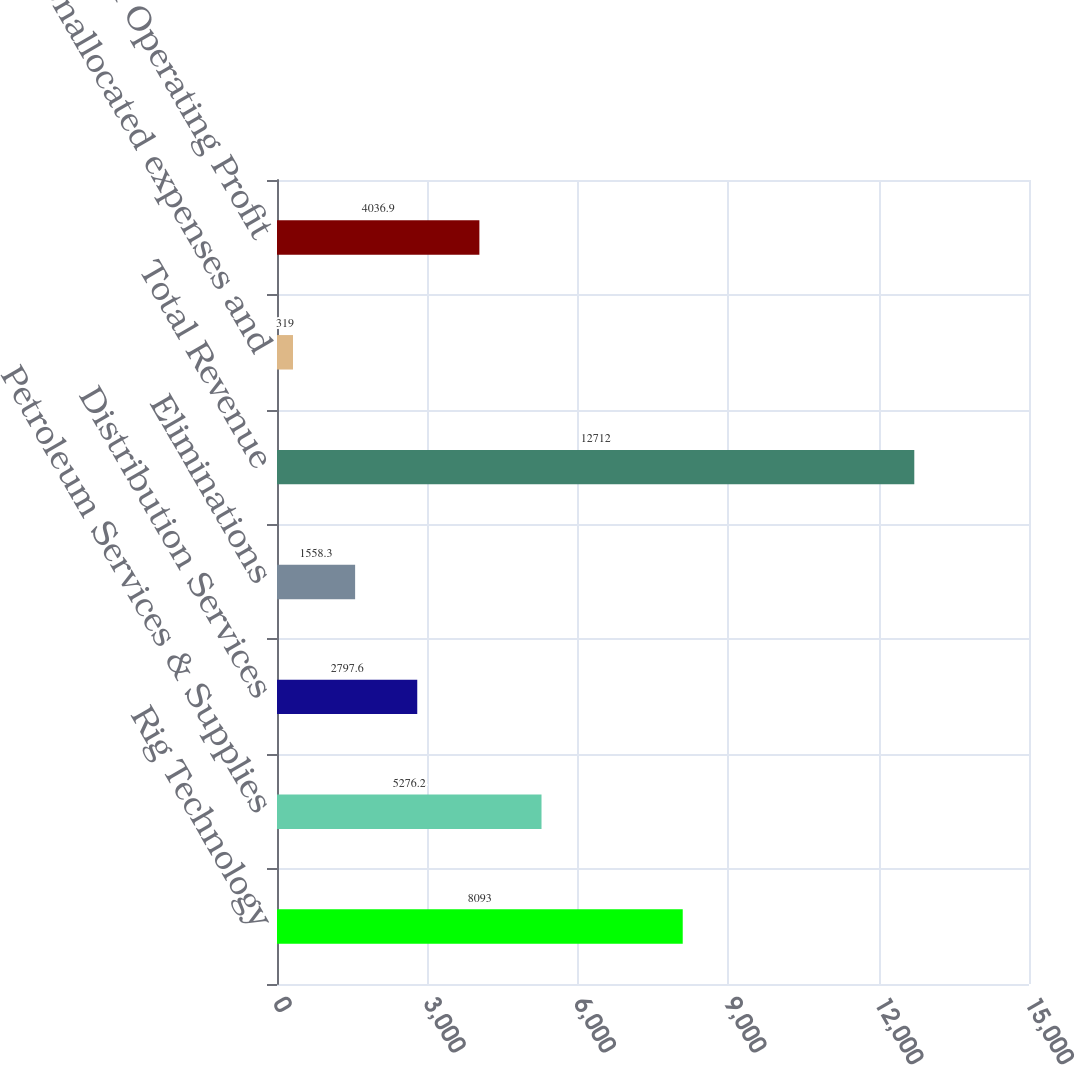Convert chart to OTSL. <chart><loc_0><loc_0><loc_500><loc_500><bar_chart><fcel>Rig Technology<fcel>Petroleum Services & Supplies<fcel>Distribution Services<fcel>Eliminations<fcel>Total Revenue<fcel>Unallocated expenses and<fcel>Total Operating Profit<nl><fcel>8093<fcel>5276.2<fcel>2797.6<fcel>1558.3<fcel>12712<fcel>319<fcel>4036.9<nl></chart> 